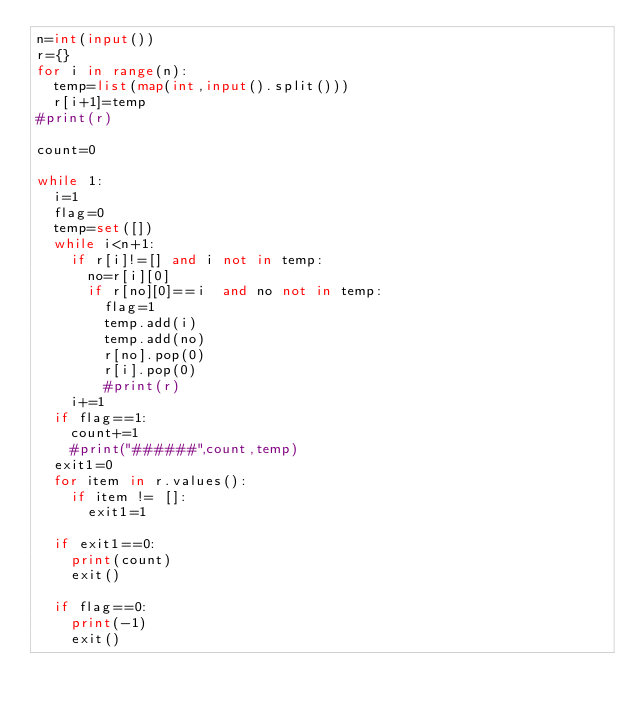<code> <loc_0><loc_0><loc_500><loc_500><_Python_>n=int(input())
r={}
for i in range(n):
  temp=list(map(int,input().split()))
  r[i+1]=temp
#print(r)

count=0

while 1:
  i=1
  flag=0
  temp=set([])
  while i<n+1:
    if r[i]!=[] and i not in temp:
      no=r[i][0]
      if r[no][0]==i  and no not in temp:
        flag=1
        temp.add(i)
        temp.add(no)
        r[no].pop(0)
        r[i].pop(0)
        #print(r)      
    i+=1
  if flag==1:
    count+=1
    #print("######",count,temp)
  exit1=0
  for item in r.values():
    if item != []:
      exit1=1
      
  if exit1==0:
    print(count)
    exit()
  
  if flag==0:
    print(-1)
    exit()

</code> 